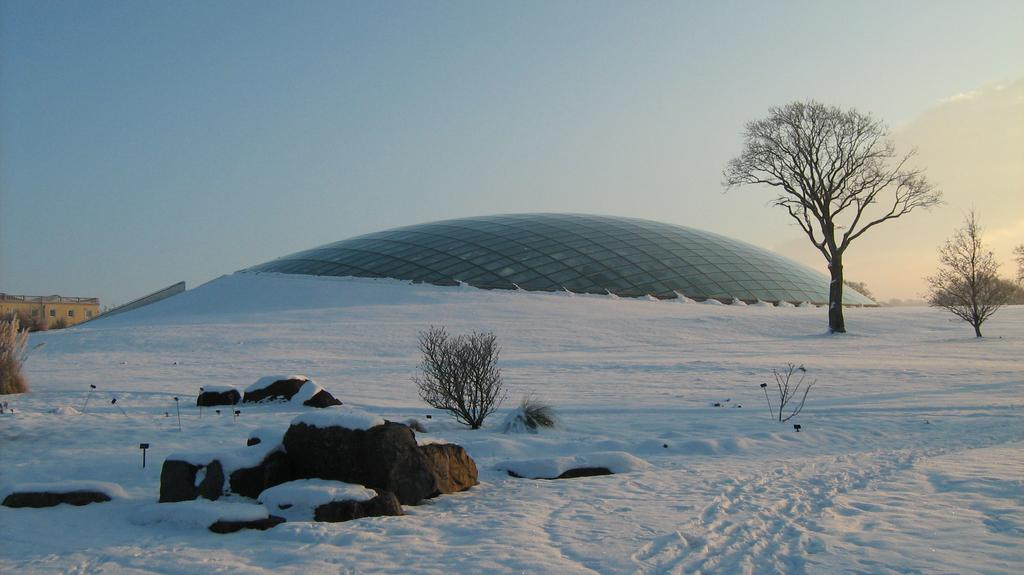What type of weather is depicted in the image? The image contains snow, indicating a cold or wintry weather. What type of natural elements can be seen in the image? There are plants, rocks, trees, and a house in the image. What is the shape of the glasses in the image? The glasses in the image are in the shape of a curve. What is visible in the background of the image? The sky is visible in the background of the image. What type of pizzas are being used as bait in the image? There are no pizzas or bait present in the image. What is the interest rate on the loan depicted in the image? There is no loan or interest rate mentioned in the image. 